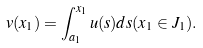<formula> <loc_0><loc_0><loc_500><loc_500>v ( x _ { 1 } ) = \int _ { a _ { 1 } } ^ { x _ { 1 } } u ( s ) d s ( x _ { 1 } \in J _ { 1 } ) .</formula> 